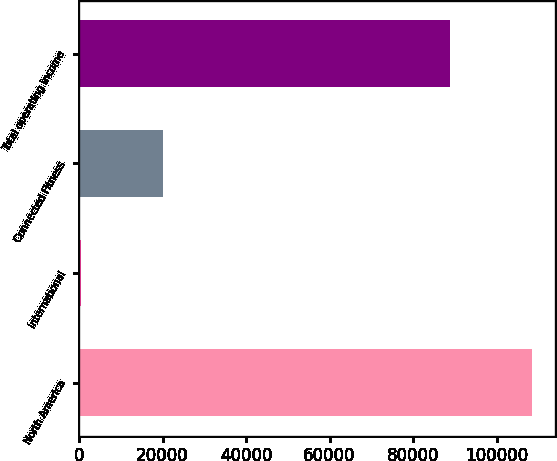<chart> <loc_0><loc_0><loc_500><loc_500><bar_chart><fcel>North America<fcel>International<fcel>Connected Fitness<fcel>Total operating income<nl><fcel>108476<fcel>516<fcel>20135<fcel>88857<nl></chart> 